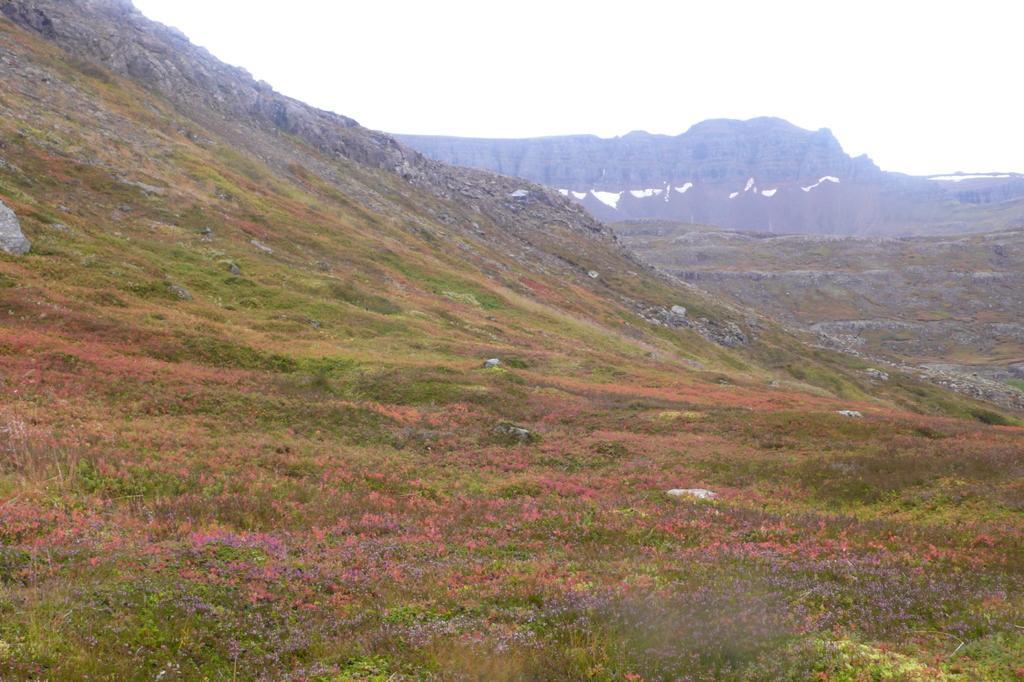How would you summarize this image in a sentence or two? In the picture there are mountains, there are plants present, there are trees, there is a clear sky. 